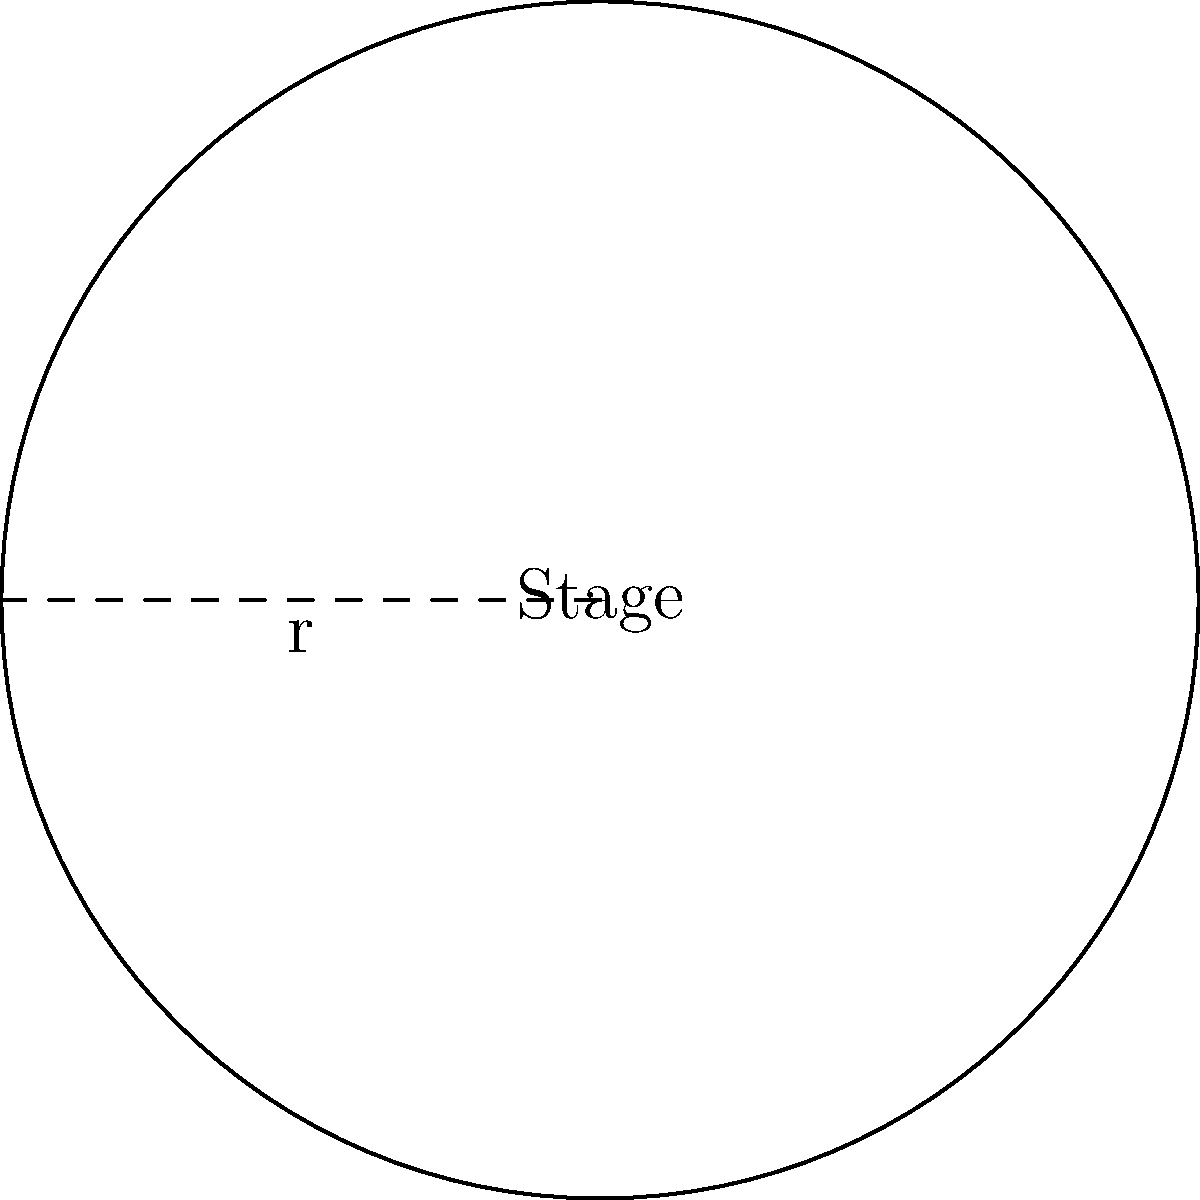As a musician, you've been invited to perform on a circular stage at a local music festival. The organizers inform you that the stage has a radius of 10 meters. What is the total area of the stage where you'll be creating your sonic disturbances? To find the area of a circular stage, we need to use the formula for the area of a circle:

$$A = \pi r^2$$

Where:
- $A$ is the area of the circle
- $\pi$ (pi) is approximately 3.14159
- $r$ is the radius of the circle

Given:
- Radius $(r) = 10$ meters

Step 1: Substitute the given radius into the formula:
$$A = \pi (10)^2$$

Step 2: Calculate the square of the radius:
$$A = \pi (100)$$

Step 3: Multiply by $\pi$:
$$A = 314.159\text{ m}^2$$

Therefore, the total area of the circular stage is approximately 314.159 square meters.
Answer: $314.159\text{ m}^2$ 